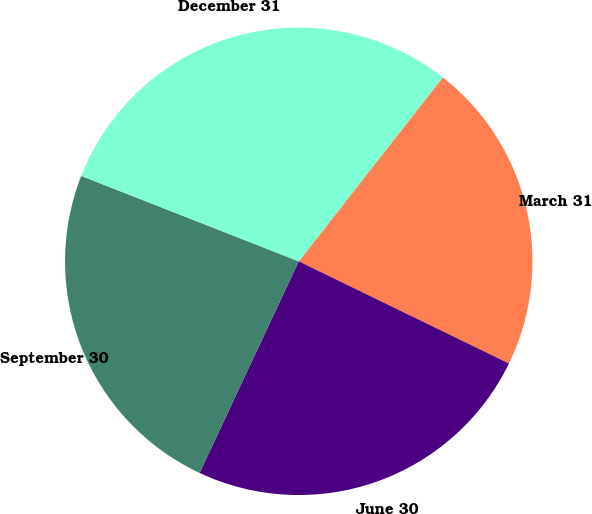Convert chart. <chart><loc_0><loc_0><loc_500><loc_500><pie_chart><fcel>March 31<fcel>June 30<fcel>September 30<fcel>December 31<nl><fcel>21.63%<fcel>24.78%<fcel>23.98%<fcel>29.62%<nl></chart> 